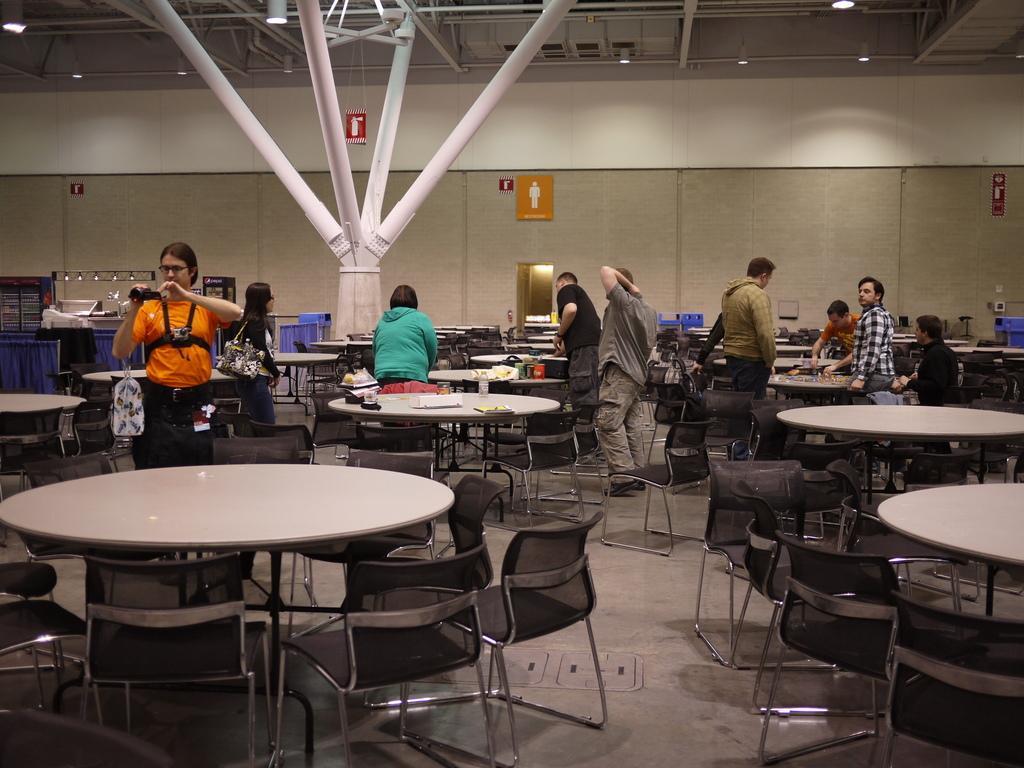How would you summarize this image in a sentence or two? In this picture there is a man holding camera in his hand. There is a woman standing and wearing a black handbag. There are few other people who are standing to the right. There is a s sign board on the wall. There are some lights on the top. There is a table and chairs. There is a book, bottle, cup and other objects on the table. There is a blue dustbin to the right side. 